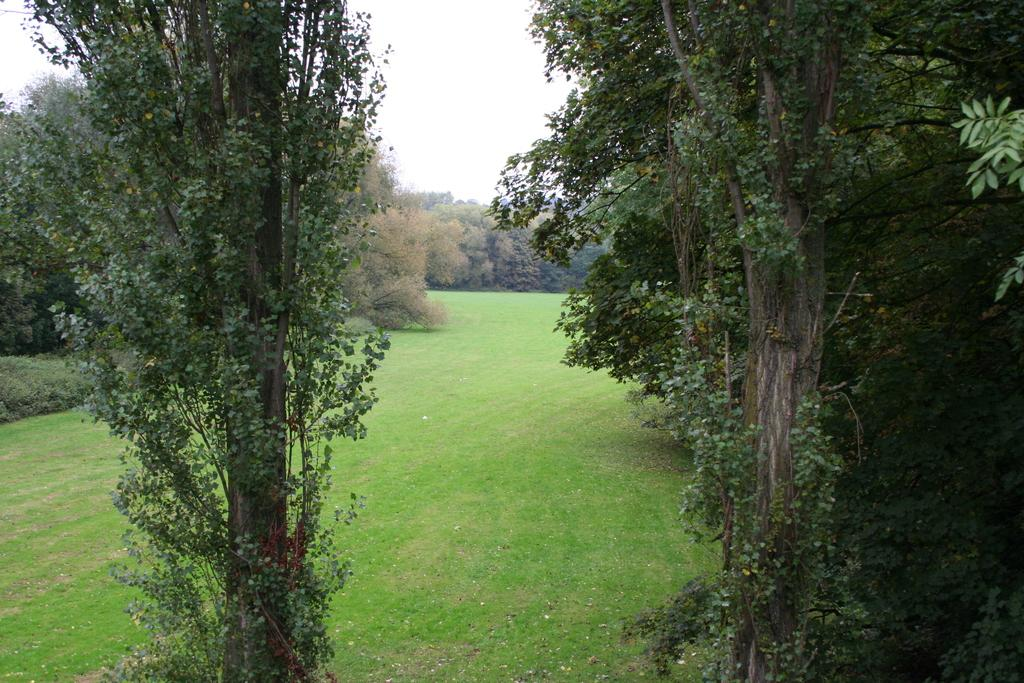What type of vegetation can be seen in the image? There is grass, plants, and trees in the image. What part of the natural environment is visible in the image? The sky is visible in the background of the image. How many types of vegetation are present in the image? There are three types of vegetation present: grass, plants, and trees. Can you see the ocean in the image? No, the ocean is not present in the image; it features grass, plants, trees, and the sky. What type of whip is being used to divide the plants in the image? There is no whip or division of plants visible in the image. 